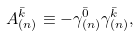<formula> <loc_0><loc_0><loc_500><loc_500>A _ { ( n ) } ^ { \bar { k } } \equiv - \gamma _ { ( n ) } ^ { \bar { 0 } } \gamma _ { ( n ) } ^ { \bar { k } } ,</formula> 